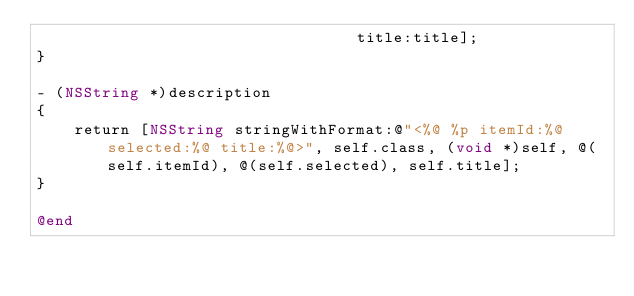Convert code to text. <code><loc_0><loc_0><loc_500><loc_500><_ObjectiveC_>                                  title:title];
}

- (NSString *)description
{
    return [NSString stringWithFormat:@"<%@ %p itemId:%@ selected:%@ title:%@>", self.class, (void *)self, @(self.itemId), @(self.selected), self.title];
}

@end
</code> 